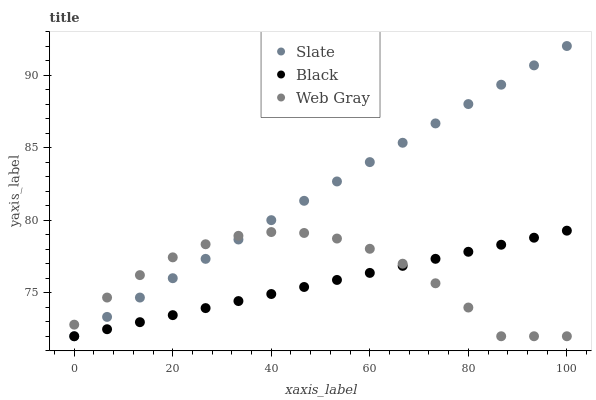Does Black have the minimum area under the curve?
Answer yes or no. Yes. Does Slate have the maximum area under the curve?
Answer yes or no. Yes. Does Web Gray have the minimum area under the curve?
Answer yes or no. No. Does Web Gray have the maximum area under the curve?
Answer yes or no. No. Is Black the smoothest?
Answer yes or no. Yes. Is Web Gray the roughest?
Answer yes or no. Yes. Is Web Gray the smoothest?
Answer yes or no. No. Is Black the roughest?
Answer yes or no. No. Does Slate have the lowest value?
Answer yes or no. Yes. Does Slate have the highest value?
Answer yes or no. Yes. Does Black have the highest value?
Answer yes or no. No. Does Black intersect Slate?
Answer yes or no. Yes. Is Black less than Slate?
Answer yes or no. No. Is Black greater than Slate?
Answer yes or no. No. 